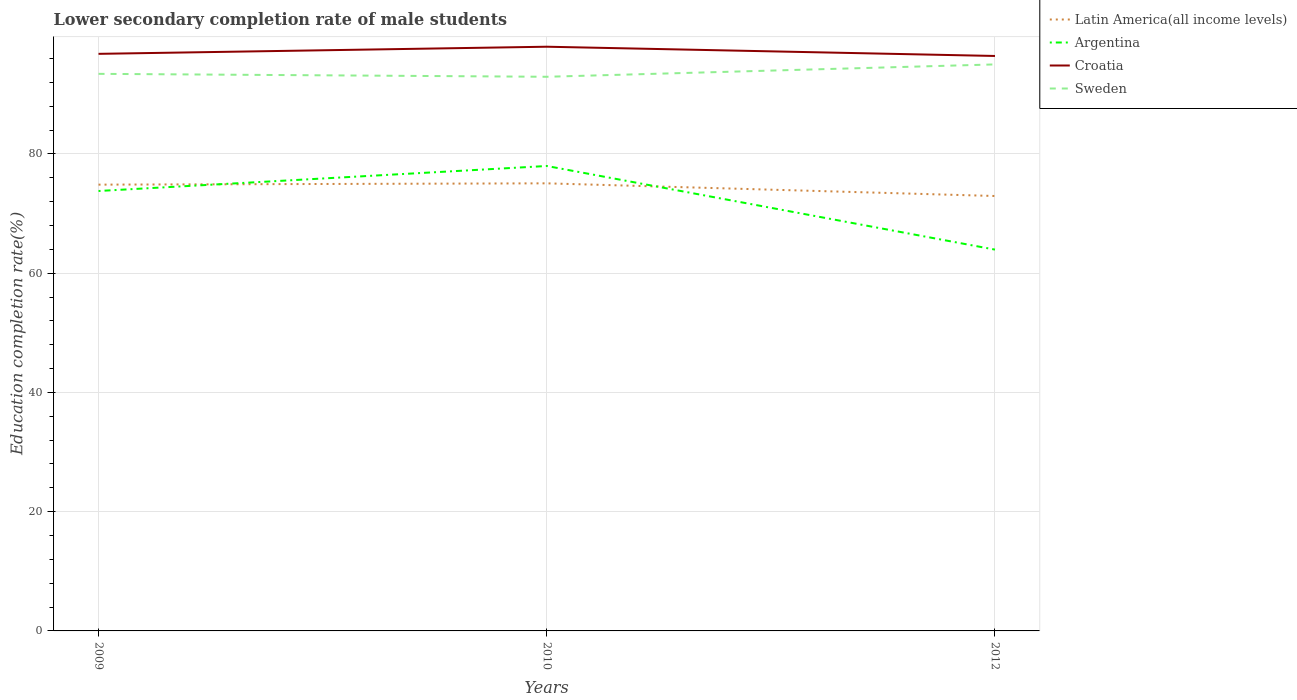How many different coloured lines are there?
Your answer should be very brief. 4. Across all years, what is the maximum lower secondary completion rate of male students in Latin America(all income levels)?
Your answer should be very brief. 72.94. What is the total lower secondary completion rate of male students in Latin America(all income levels) in the graph?
Offer a terse response. -0.22. What is the difference between the highest and the second highest lower secondary completion rate of male students in Argentina?
Make the answer very short. 14.02. How many lines are there?
Make the answer very short. 4. How many years are there in the graph?
Your response must be concise. 3. What is the difference between two consecutive major ticks on the Y-axis?
Provide a succinct answer. 20. Does the graph contain any zero values?
Provide a short and direct response. No. Where does the legend appear in the graph?
Offer a very short reply. Top right. What is the title of the graph?
Offer a terse response. Lower secondary completion rate of male students. What is the label or title of the Y-axis?
Offer a very short reply. Education completion rate(%). What is the Education completion rate(%) of Latin America(all income levels) in 2009?
Provide a succinct answer. 74.85. What is the Education completion rate(%) in Argentina in 2009?
Your answer should be compact. 73.78. What is the Education completion rate(%) of Croatia in 2009?
Make the answer very short. 96.78. What is the Education completion rate(%) in Sweden in 2009?
Keep it short and to the point. 93.43. What is the Education completion rate(%) in Latin America(all income levels) in 2010?
Your response must be concise. 75.07. What is the Education completion rate(%) in Argentina in 2010?
Your answer should be very brief. 77.97. What is the Education completion rate(%) in Croatia in 2010?
Ensure brevity in your answer.  97.98. What is the Education completion rate(%) in Sweden in 2010?
Keep it short and to the point. 92.94. What is the Education completion rate(%) of Latin America(all income levels) in 2012?
Provide a short and direct response. 72.94. What is the Education completion rate(%) of Argentina in 2012?
Provide a succinct answer. 63.95. What is the Education completion rate(%) in Croatia in 2012?
Make the answer very short. 96.42. What is the Education completion rate(%) of Sweden in 2012?
Your response must be concise. 95.01. Across all years, what is the maximum Education completion rate(%) in Latin America(all income levels)?
Your answer should be compact. 75.07. Across all years, what is the maximum Education completion rate(%) of Argentina?
Your response must be concise. 77.97. Across all years, what is the maximum Education completion rate(%) of Croatia?
Keep it short and to the point. 97.98. Across all years, what is the maximum Education completion rate(%) of Sweden?
Provide a succinct answer. 95.01. Across all years, what is the minimum Education completion rate(%) of Latin America(all income levels)?
Offer a terse response. 72.94. Across all years, what is the minimum Education completion rate(%) of Argentina?
Provide a succinct answer. 63.95. Across all years, what is the minimum Education completion rate(%) in Croatia?
Your answer should be compact. 96.42. Across all years, what is the minimum Education completion rate(%) of Sweden?
Keep it short and to the point. 92.94. What is the total Education completion rate(%) in Latin America(all income levels) in the graph?
Your answer should be very brief. 222.85. What is the total Education completion rate(%) of Argentina in the graph?
Provide a succinct answer. 215.71. What is the total Education completion rate(%) of Croatia in the graph?
Provide a succinct answer. 291.18. What is the total Education completion rate(%) in Sweden in the graph?
Offer a very short reply. 281.37. What is the difference between the Education completion rate(%) of Latin America(all income levels) in 2009 and that in 2010?
Your answer should be very brief. -0.22. What is the difference between the Education completion rate(%) of Argentina in 2009 and that in 2010?
Ensure brevity in your answer.  -4.19. What is the difference between the Education completion rate(%) in Croatia in 2009 and that in 2010?
Provide a succinct answer. -1.19. What is the difference between the Education completion rate(%) of Sweden in 2009 and that in 2010?
Your answer should be very brief. 0.49. What is the difference between the Education completion rate(%) of Latin America(all income levels) in 2009 and that in 2012?
Keep it short and to the point. 1.91. What is the difference between the Education completion rate(%) in Argentina in 2009 and that in 2012?
Make the answer very short. 9.83. What is the difference between the Education completion rate(%) of Croatia in 2009 and that in 2012?
Offer a very short reply. 0.36. What is the difference between the Education completion rate(%) in Sweden in 2009 and that in 2012?
Your response must be concise. -1.58. What is the difference between the Education completion rate(%) in Latin America(all income levels) in 2010 and that in 2012?
Make the answer very short. 2.13. What is the difference between the Education completion rate(%) of Argentina in 2010 and that in 2012?
Keep it short and to the point. 14.02. What is the difference between the Education completion rate(%) of Croatia in 2010 and that in 2012?
Your answer should be compact. 1.55. What is the difference between the Education completion rate(%) of Sweden in 2010 and that in 2012?
Offer a very short reply. -2.07. What is the difference between the Education completion rate(%) of Latin America(all income levels) in 2009 and the Education completion rate(%) of Argentina in 2010?
Give a very brief answer. -3.13. What is the difference between the Education completion rate(%) in Latin America(all income levels) in 2009 and the Education completion rate(%) in Croatia in 2010?
Ensure brevity in your answer.  -23.13. What is the difference between the Education completion rate(%) in Latin America(all income levels) in 2009 and the Education completion rate(%) in Sweden in 2010?
Offer a terse response. -18.09. What is the difference between the Education completion rate(%) in Argentina in 2009 and the Education completion rate(%) in Croatia in 2010?
Your answer should be compact. -24.2. What is the difference between the Education completion rate(%) of Argentina in 2009 and the Education completion rate(%) of Sweden in 2010?
Your response must be concise. -19.16. What is the difference between the Education completion rate(%) of Croatia in 2009 and the Education completion rate(%) of Sweden in 2010?
Ensure brevity in your answer.  3.85. What is the difference between the Education completion rate(%) of Latin America(all income levels) in 2009 and the Education completion rate(%) of Argentina in 2012?
Keep it short and to the point. 10.9. What is the difference between the Education completion rate(%) in Latin America(all income levels) in 2009 and the Education completion rate(%) in Croatia in 2012?
Keep it short and to the point. -21.58. What is the difference between the Education completion rate(%) of Latin America(all income levels) in 2009 and the Education completion rate(%) of Sweden in 2012?
Offer a very short reply. -20.16. What is the difference between the Education completion rate(%) in Argentina in 2009 and the Education completion rate(%) in Croatia in 2012?
Give a very brief answer. -22.64. What is the difference between the Education completion rate(%) of Argentina in 2009 and the Education completion rate(%) of Sweden in 2012?
Offer a very short reply. -21.23. What is the difference between the Education completion rate(%) in Croatia in 2009 and the Education completion rate(%) in Sweden in 2012?
Your answer should be very brief. 1.77. What is the difference between the Education completion rate(%) of Latin America(all income levels) in 2010 and the Education completion rate(%) of Argentina in 2012?
Your response must be concise. 11.12. What is the difference between the Education completion rate(%) in Latin America(all income levels) in 2010 and the Education completion rate(%) in Croatia in 2012?
Your answer should be compact. -21.36. What is the difference between the Education completion rate(%) in Latin America(all income levels) in 2010 and the Education completion rate(%) in Sweden in 2012?
Provide a succinct answer. -19.94. What is the difference between the Education completion rate(%) in Argentina in 2010 and the Education completion rate(%) in Croatia in 2012?
Your answer should be very brief. -18.45. What is the difference between the Education completion rate(%) in Argentina in 2010 and the Education completion rate(%) in Sweden in 2012?
Offer a terse response. -17.04. What is the difference between the Education completion rate(%) in Croatia in 2010 and the Education completion rate(%) in Sweden in 2012?
Provide a succinct answer. 2.97. What is the average Education completion rate(%) in Latin America(all income levels) per year?
Your answer should be compact. 74.28. What is the average Education completion rate(%) in Argentina per year?
Your response must be concise. 71.9. What is the average Education completion rate(%) of Croatia per year?
Provide a succinct answer. 97.06. What is the average Education completion rate(%) of Sweden per year?
Offer a terse response. 93.79. In the year 2009, what is the difference between the Education completion rate(%) of Latin America(all income levels) and Education completion rate(%) of Argentina?
Provide a succinct answer. 1.07. In the year 2009, what is the difference between the Education completion rate(%) in Latin America(all income levels) and Education completion rate(%) in Croatia?
Keep it short and to the point. -21.94. In the year 2009, what is the difference between the Education completion rate(%) of Latin America(all income levels) and Education completion rate(%) of Sweden?
Your answer should be compact. -18.58. In the year 2009, what is the difference between the Education completion rate(%) in Argentina and Education completion rate(%) in Croatia?
Provide a short and direct response. -23. In the year 2009, what is the difference between the Education completion rate(%) in Argentina and Education completion rate(%) in Sweden?
Keep it short and to the point. -19.65. In the year 2009, what is the difference between the Education completion rate(%) of Croatia and Education completion rate(%) of Sweden?
Provide a succinct answer. 3.36. In the year 2010, what is the difference between the Education completion rate(%) in Latin America(all income levels) and Education completion rate(%) in Argentina?
Provide a succinct answer. -2.91. In the year 2010, what is the difference between the Education completion rate(%) in Latin America(all income levels) and Education completion rate(%) in Croatia?
Your answer should be very brief. -22.91. In the year 2010, what is the difference between the Education completion rate(%) of Latin America(all income levels) and Education completion rate(%) of Sweden?
Provide a succinct answer. -17.87. In the year 2010, what is the difference between the Education completion rate(%) in Argentina and Education completion rate(%) in Croatia?
Keep it short and to the point. -20. In the year 2010, what is the difference between the Education completion rate(%) of Argentina and Education completion rate(%) of Sweden?
Your answer should be compact. -14.96. In the year 2010, what is the difference between the Education completion rate(%) in Croatia and Education completion rate(%) in Sweden?
Your answer should be compact. 5.04. In the year 2012, what is the difference between the Education completion rate(%) of Latin America(all income levels) and Education completion rate(%) of Argentina?
Ensure brevity in your answer.  8.99. In the year 2012, what is the difference between the Education completion rate(%) in Latin America(all income levels) and Education completion rate(%) in Croatia?
Your response must be concise. -23.48. In the year 2012, what is the difference between the Education completion rate(%) of Latin America(all income levels) and Education completion rate(%) of Sweden?
Your answer should be compact. -22.07. In the year 2012, what is the difference between the Education completion rate(%) in Argentina and Education completion rate(%) in Croatia?
Keep it short and to the point. -32.47. In the year 2012, what is the difference between the Education completion rate(%) of Argentina and Education completion rate(%) of Sweden?
Give a very brief answer. -31.06. In the year 2012, what is the difference between the Education completion rate(%) of Croatia and Education completion rate(%) of Sweden?
Keep it short and to the point. 1.41. What is the ratio of the Education completion rate(%) of Argentina in 2009 to that in 2010?
Keep it short and to the point. 0.95. What is the ratio of the Education completion rate(%) in Latin America(all income levels) in 2009 to that in 2012?
Your answer should be very brief. 1.03. What is the ratio of the Education completion rate(%) in Argentina in 2009 to that in 2012?
Offer a terse response. 1.15. What is the ratio of the Education completion rate(%) of Sweden in 2009 to that in 2012?
Provide a short and direct response. 0.98. What is the ratio of the Education completion rate(%) in Latin America(all income levels) in 2010 to that in 2012?
Provide a succinct answer. 1.03. What is the ratio of the Education completion rate(%) in Argentina in 2010 to that in 2012?
Make the answer very short. 1.22. What is the ratio of the Education completion rate(%) of Croatia in 2010 to that in 2012?
Your answer should be compact. 1.02. What is the ratio of the Education completion rate(%) of Sweden in 2010 to that in 2012?
Provide a succinct answer. 0.98. What is the difference between the highest and the second highest Education completion rate(%) in Latin America(all income levels)?
Give a very brief answer. 0.22. What is the difference between the highest and the second highest Education completion rate(%) of Argentina?
Your answer should be compact. 4.19. What is the difference between the highest and the second highest Education completion rate(%) of Croatia?
Your answer should be very brief. 1.19. What is the difference between the highest and the second highest Education completion rate(%) in Sweden?
Provide a short and direct response. 1.58. What is the difference between the highest and the lowest Education completion rate(%) of Latin America(all income levels)?
Offer a very short reply. 2.13. What is the difference between the highest and the lowest Education completion rate(%) of Argentina?
Ensure brevity in your answer.  14.02. What is the difference between the highest and the lowest Education completion rate(%) of Croatia?
Make the answer very short. 1.55. What is the difference between the highest and the lowest Education completion rate(%) of Sweden?
Keep it short and to the point. 2.07. 